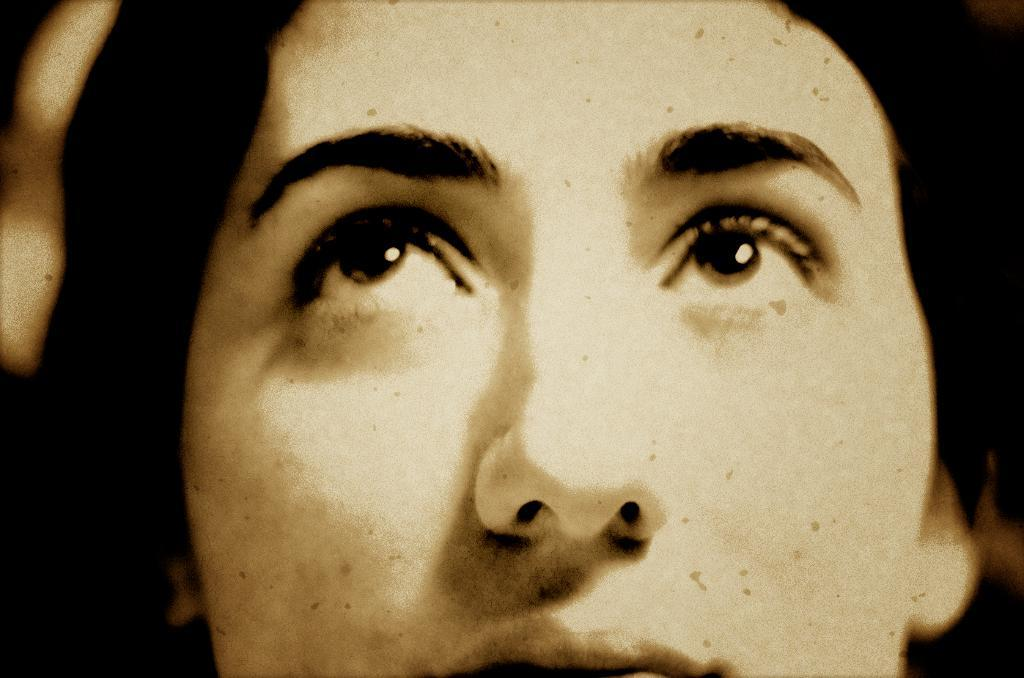What is the main subject of the image? There is a person's face in the image. How many spiders are crawling on the person's face in the image? There are no spiders present in the image; it only features a person's face. What type of tree is visible behind the person's face in the image? There is no tree visible in the image; it only features a person's face. 